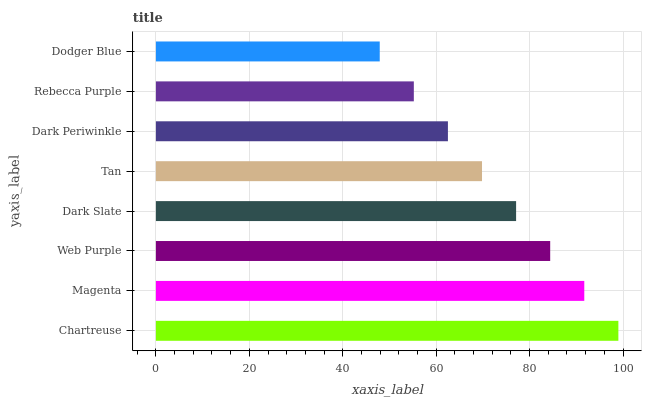Is Dodger Blue the minimum?
Answer yes or no. Yes. Is Chartreuse the maximum?
Answer yes or no. Yes. Is Magenta the minimum?
Answer yes or no. No. Is Magenta the maximum?
Answer yes or no. No. Is Chartreuse greater than Magenta?
Answer yes or no. Yes. Is Magenta less than Chartreuse?
Answer yes or no. Yes. Is Magenta greater than Chartreuse?
Answer yes or no. No. Is Chartreuse less than Magenta?
Answer yes or no. No. Is Dark Slate the high median?
Answer yes or no. Yes. Is Tan the low median?
Answer yes or no. Yes. Is Dark Periwinkle the high median?
Answer yes or no. No. Is Web Purple the low median?
Answer yes or no. No. 